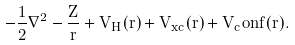Convert formula to latex. <formula><loc_0><loc_0><loc_500><loc_500>- \frac { 1 } { 2 } \nabla ^ { 2 } - \frac { Z } { r } + V _ { H } ( r ) + V _ { x c } ( r ) + V _ { c } o n f ( r ) .</formula> 